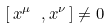Convert formula to latex. <formula><loc_0><loc_0><loc_500><loc_500>\left [ \, x ^ { \mu } \ , x ^ { \nu } \, \right ] \ne 0</formula> 